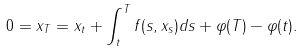<formula> <loc_0><loc_0><loc_500><loc_500>0 = x _ { T } = x _ { t } + \int _ { t } ^ { T } f ( s , x _ { s } ) d s + \varphi ( T ) - \varphi ( t ) .</formula> 